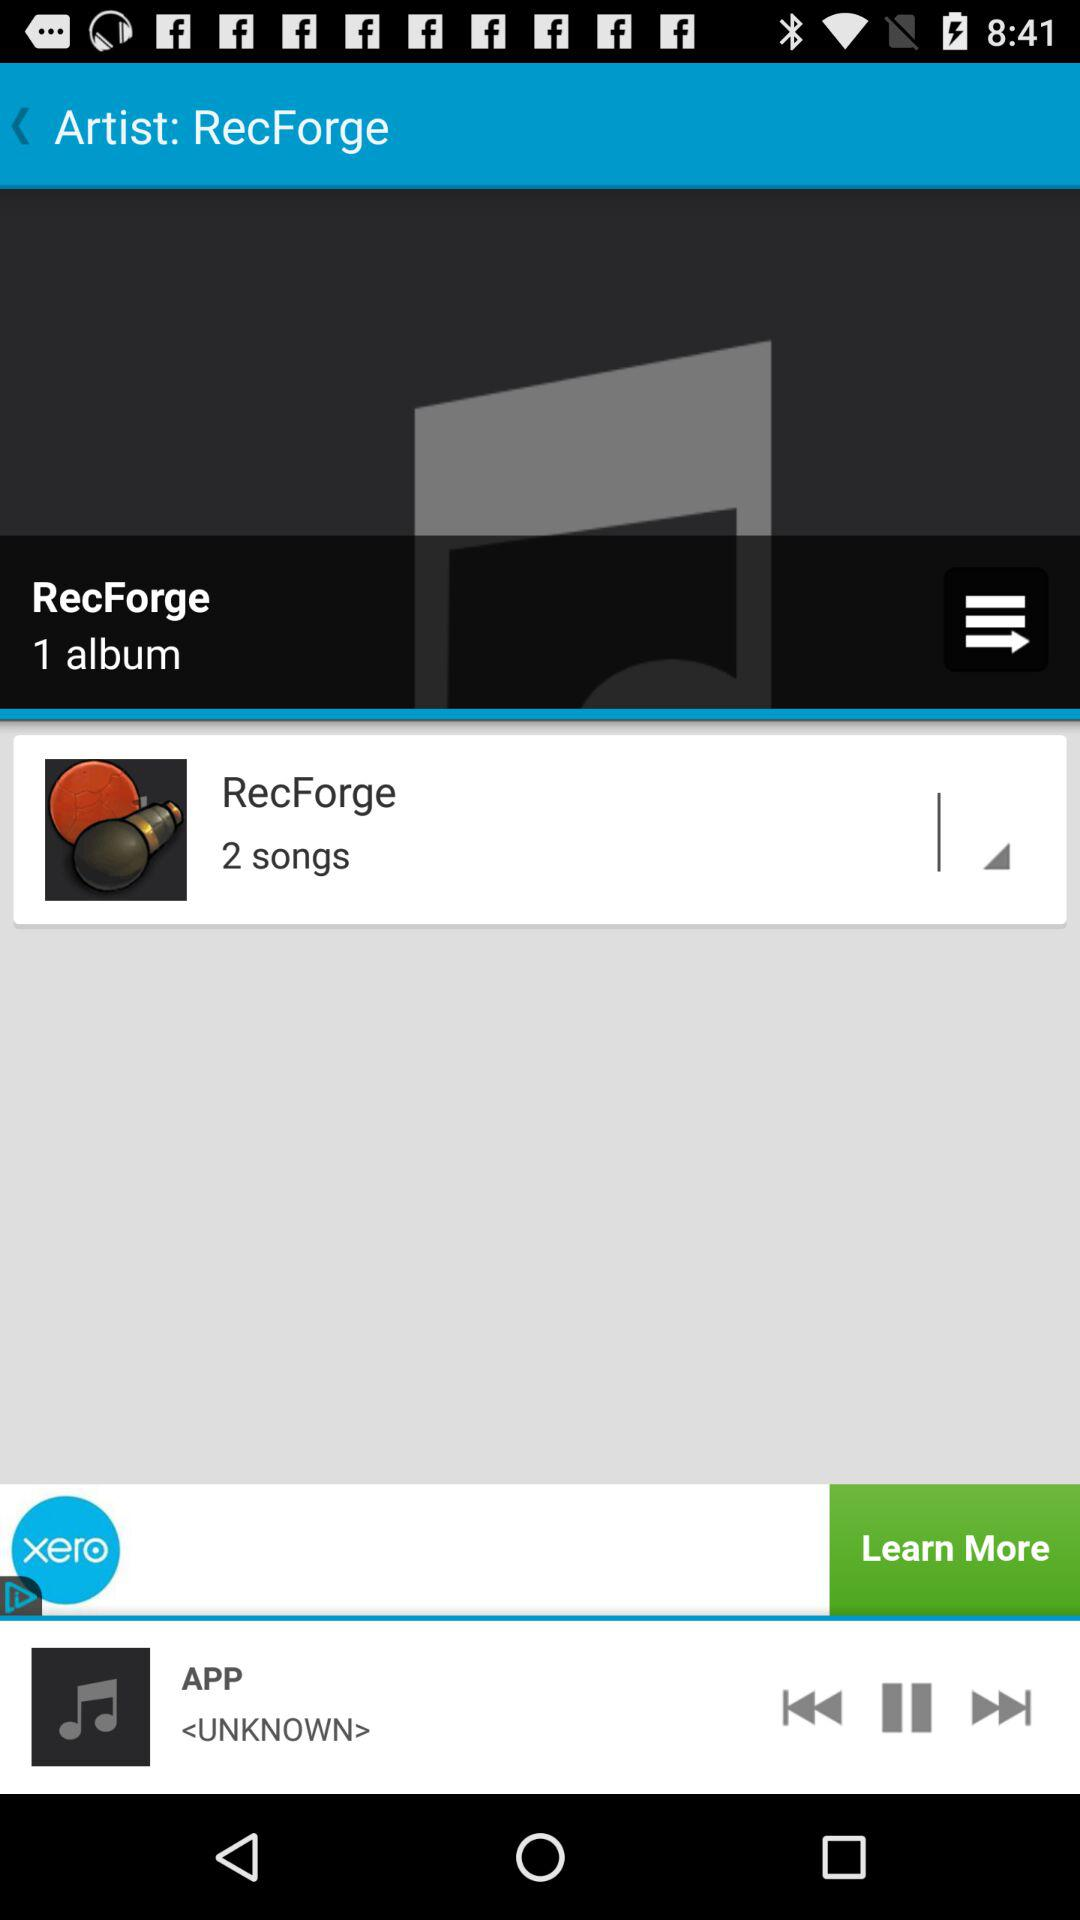How many more songs does the album have than the artist has?
Answer the question using a single word or phrase. 1 